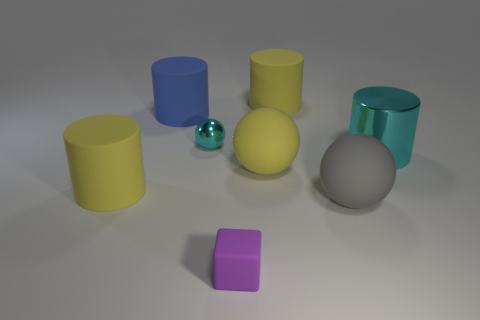Add 2 large gray balls. How many objects exist? 10 Subtract all cubes. How many objects are left? 7 Add 6 big cyan objects. How many big cyan objects are left? 7 Add 6 purple rubber objects. How many purple rubber objects exist? 7 Subtract 0 brown cylinders. How many objects are left? 8 Subtract all cylinders. Subtract all large yellow objects. How many objects are left? 1 